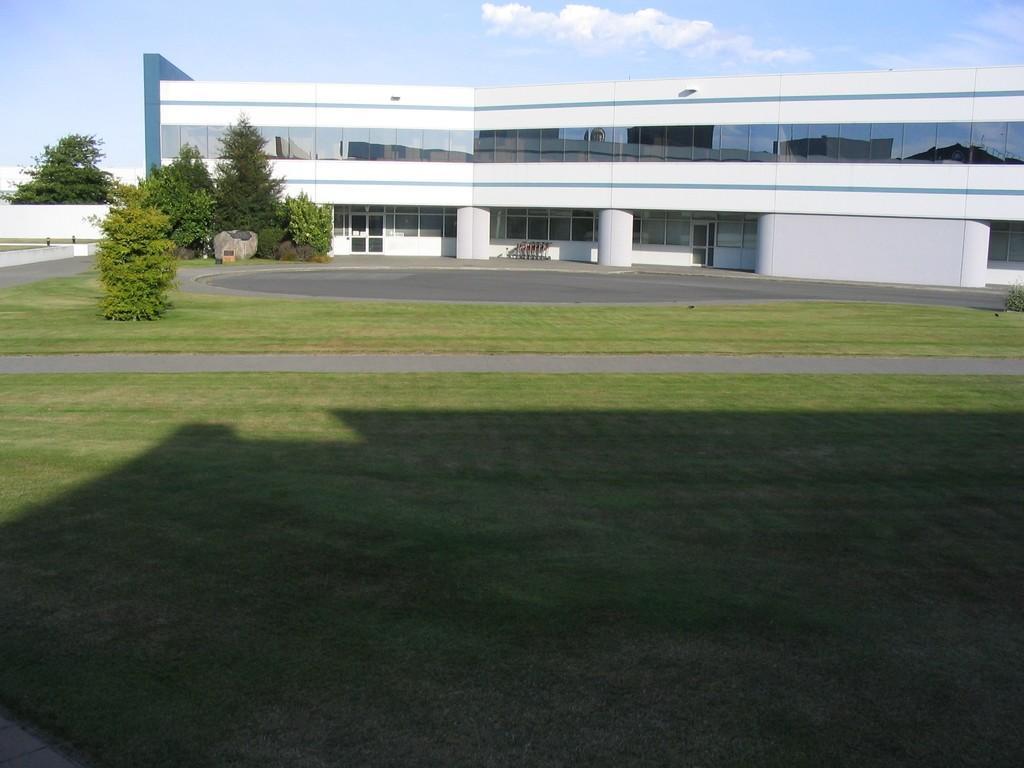Could you give a brief overview of what you see in this image? In the foreground of the picture there is grass. In the center of the picture there are trees, grass, windows, wall, road and a building. It is sunny. 